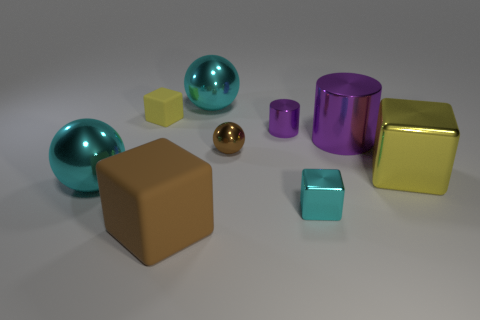Is the yellow object to the left of the large yellow thing made of the same material as the large cube on the left side of the yellow metallic thing?
Offer a very short reply. Yes. What number of things are either metal objects on the right side of the small cyan thing or purple objects?
Keep it short and to the point. 3. Is the number of large objects that are on the right side of the big brown rubber thing less than the number of large things that are behind the large yellow object?
Ensure brevity in your answer.  No. What number of other objects are the same size as the yellow shiny block?
Your answer should be compact. 4. Is the tiny brown object made of the same material as the yellow cube to the left of the tiny shiny cylinder?
Your answer should be compact. No. How many objects are either shiny balls that are on the left side of the large rubber cube or big spheres behind the big brown cube?
Keep it short and to the point. 2. What color is the tiny shiny cube?
Keep it short and to the point. Cyan. Is the number of big rubber things behind the tiny brown sphere less than the number of tiny cyan things?
Your answer should be compact. Yes. Is there any other thing that has the same shape as the small brown object?
Make the answer very short. Yes. Is there a big purple cylinder?
Offer a terse response. Yes. 